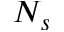<formula> <loc_0><loc_0><loc_500><loc_500>N _ { s }</formula> 